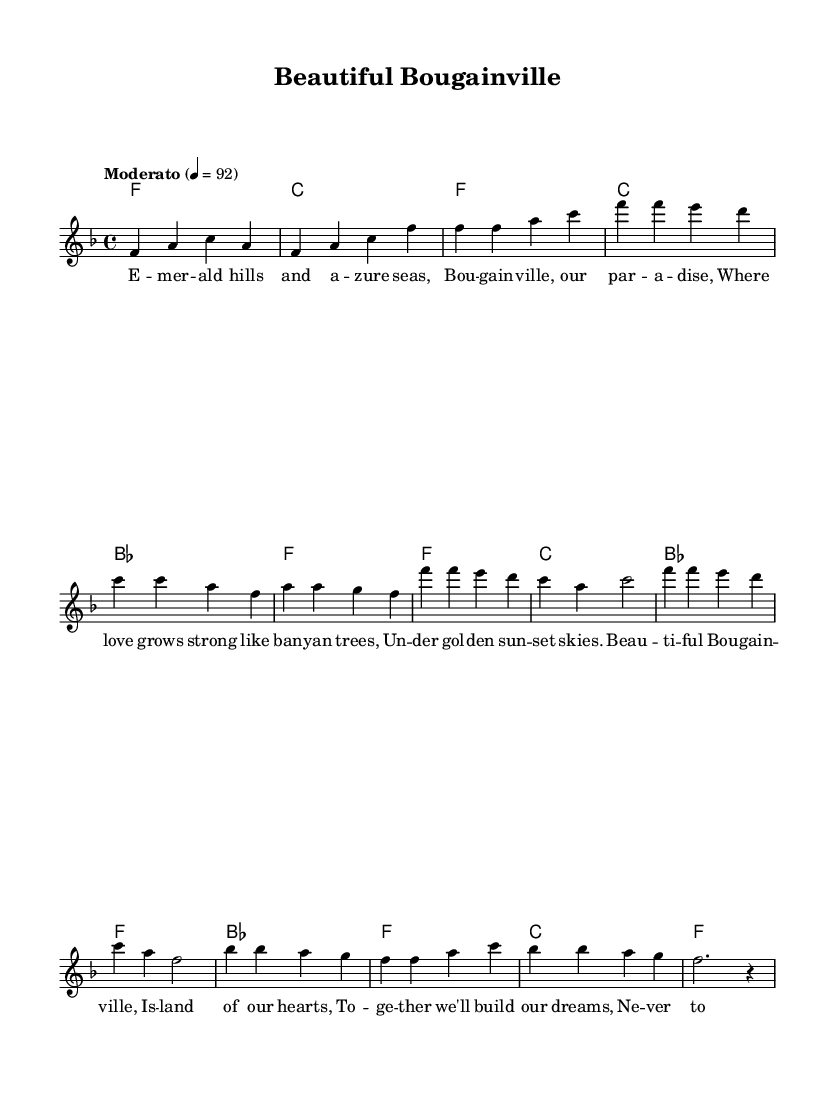What is the key signature of this music? The key signature is F major, indicated by one flat (B flat). This is shown at the beginning of the staff where the key signature is placed.
Answer: F major What is the time signature of this music? The time signature is 4/4, which means there are four beats in each measure and a quarter note gets one beat. This is indicated at the beginning of the sheet music next to the key signature.
Answer: 4/4 What is the tempo marking for this piece? The tempo marking is "Moderato," which suggests a moderate speed for the performance. It is indicated above the staff alongside a metronome marking of 92 beats per minute.
Answer: Moderato How many measures are in the chorus section? The chorus section contains four measures, as indicated in the music where the melodic and harmonic patterns repeat after the verse. This can be counted by looking at the notation specifically labeled as the chorus.
Answer: Four What is the pattern of the harmony during the bridge? The harmony during the bridge follows a pattern of B flat, F, C, and F. This can be seen by examining the chord symbols written above the staff in the bridge section of the music.
Answer: B flat, F, C, F What emotion does the lyrics convey in the chorus? The lyrics in the chorus convey a sense of unity and hope, evident from phrases like "Together we'll build our dreams." This reflects a romantic theme typical in uplifting love songs which celebrate community and connection.
Answer: Unity and hope What unique rhythmic feature is present in the melody? The unique rhythmic feature present in the melody is the use of longer note values in the bridge, such as half notes and whole notes, which provides a contrast to the quicker rhythms of the verse and chorus. This adds a sense of lifting and expansive quality to the piece.
Answer: Longer note values 